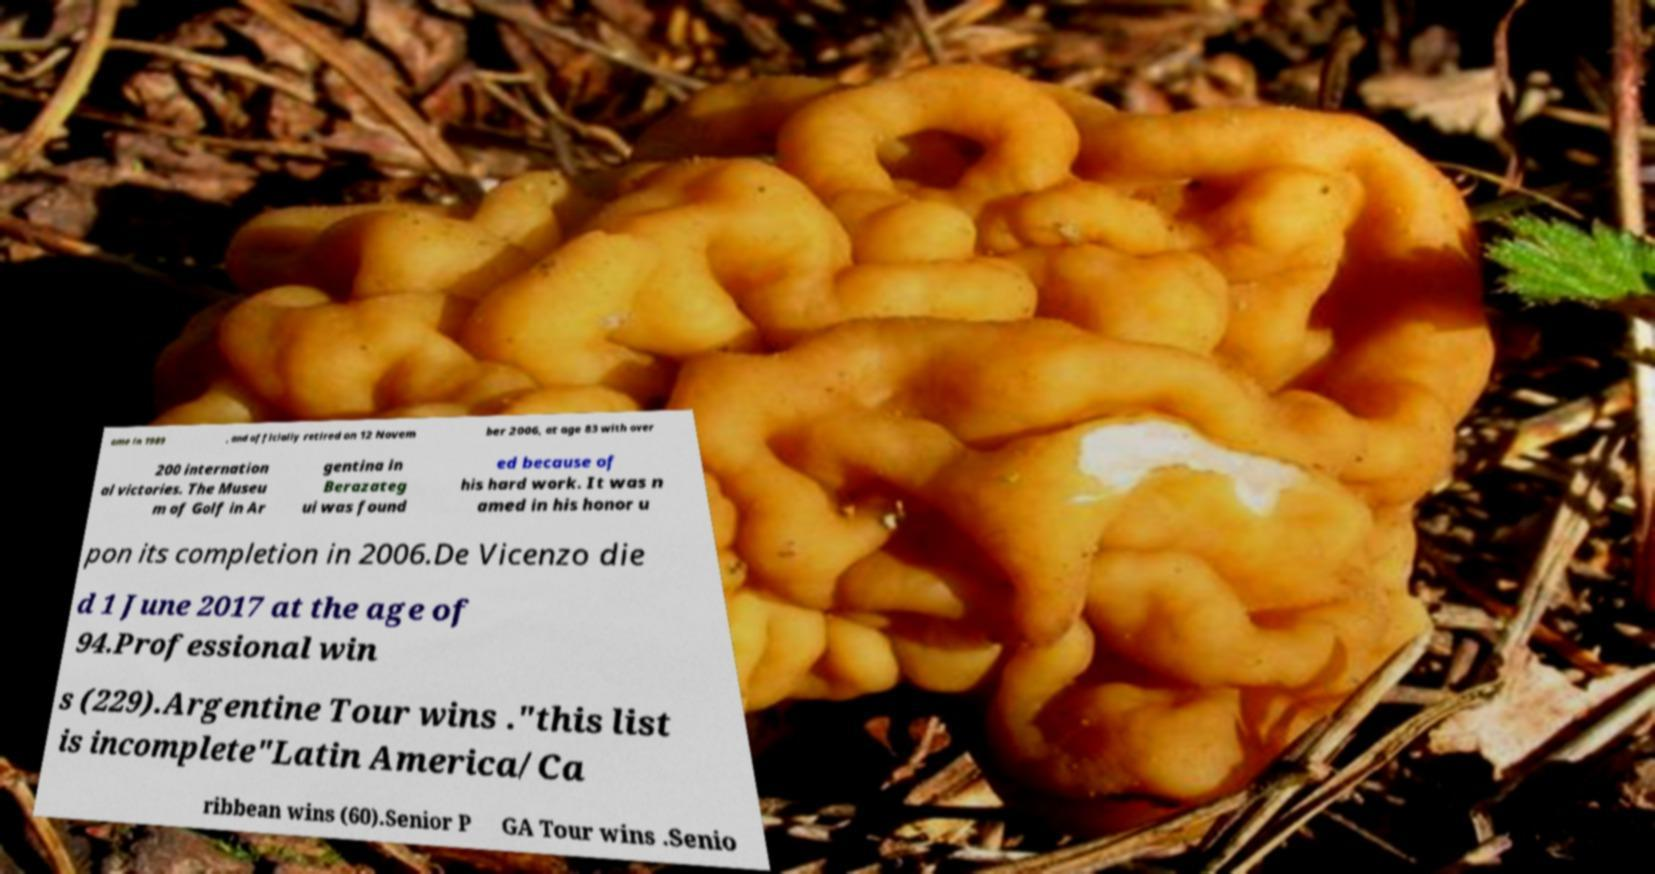There's text embedded in this image that I need extracted. Can you transcribe it verbatim? ame in 1989 , and officially retired on 12 Novem ber 2006, at age 83 with over 200 internation al victories. The Museu m of Golf in Ar gentina in Berazateg ui was found ed because of his hard work. It was n amed in his honor u pon its completion in 2006.De Vicenzo die d 1 June 2017 at the age of 94.Professional win s (229).Argentine Tour wins ."this list is incomplete"Latin America/Ca ribbean wins (60).Senior P GA Tour wins .Senio 